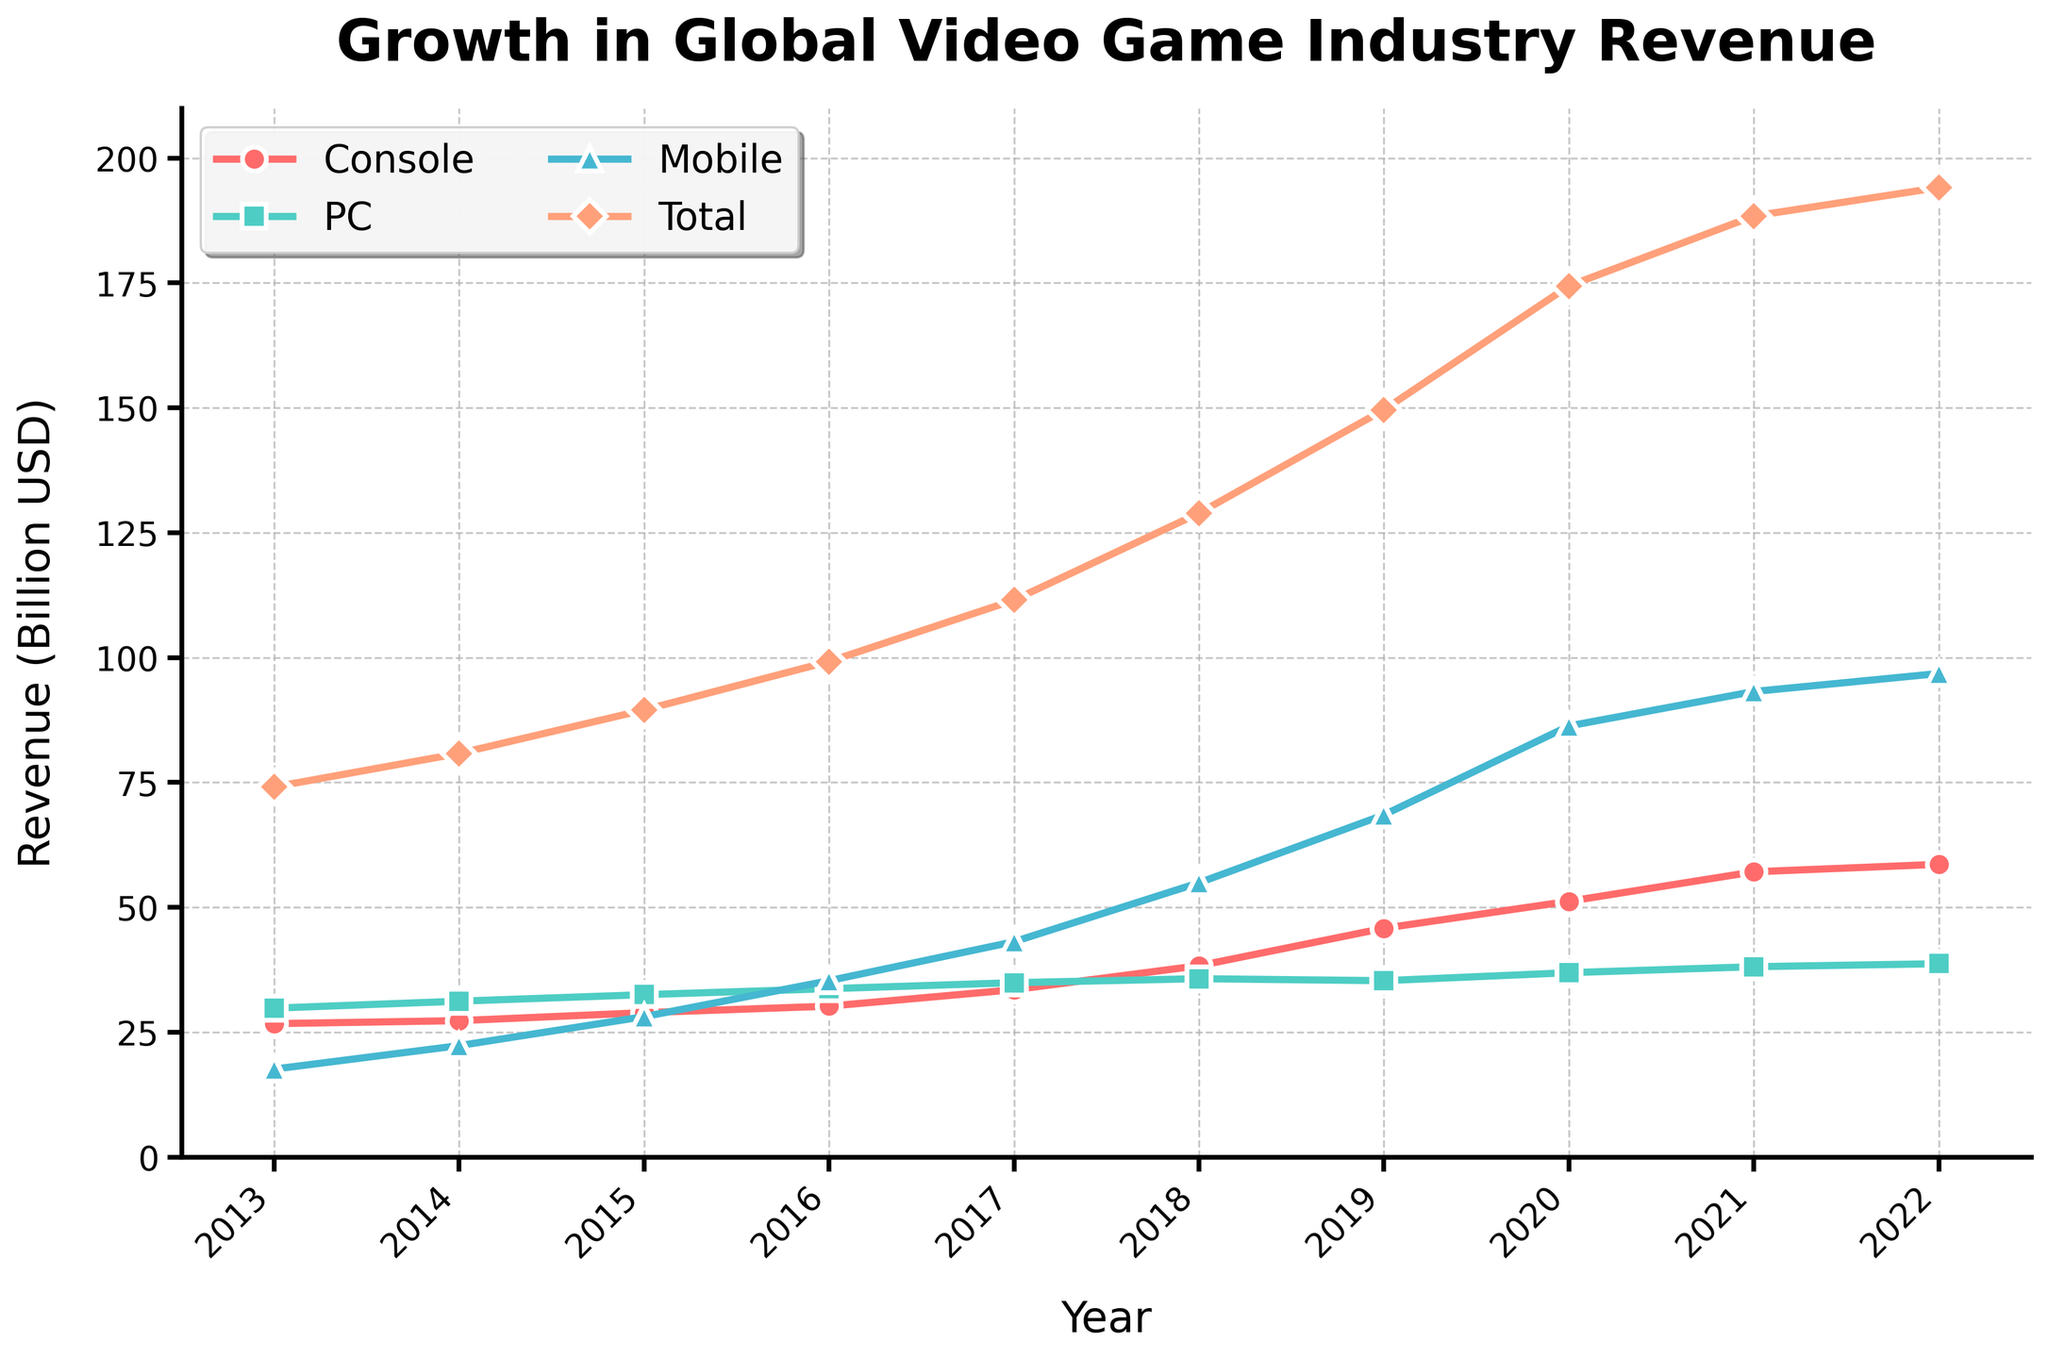Which platform had the highest revenue in 2022? The chart shows revenue for different platforms. In 2022, the Mobile platform's line is the highest, indicating it had the highest revenue.
Answer: Mobile How did the total revenue change from 2013 to 2022? In the chart, the Total revenue line starts at 74.1 billion USD in 2013 and increases to 194.1 billion USD in 2022. Subtracting the 2013 value from the 2022 value: 194.1 - 74.1 = 120 billion USD.
Answer: Increased by 120 billion USD Which year saw the biggest increase in Mobile revenue? The chart visually shows changes in Mobile revenue. The steepest increase appears between 2017 (43.1 billion USD) and 2018 (54.9 billion USD), a difference of 11.8 billion USD.
Answer: 2017 to 2018 Compare Console and PC revenue in 2020. Which was higher? In the chart, observe the lines for Console and PC in 2020. Console revenue is 51.2 billion USD, and PC revenue is 36.9 billion USD. Console revenue is higher.
Answer: Console What is the average annual revenue for the PC platform over the period? Sum the PC revenue values for each year and divide by the number of years: (29.8 + 31.2 + 32.5 + 33.7 + 34.9 + 35.7 + 35.3 + 36.9 + 38.1 + 38.7) / 10 = 34.68 billion USD.
Answer: 34.68 billion USD In which year did Mobile revenue surpass Console revenue? Identify the first year when the Mobile line is above the Console line. This occurs in 2016, where Mobile revenue (35.3 billion USD) surpasses Console revenue (30.2 billion USD).
Answer: 2016 What is the combined revenue of Console and PC platforms in 2021? Add Console and PC revenue for 2021: 57.1 (Console) + 38.1 (PC) = 95.2 billion USD.
Answer: 95.2 billion USD Which platform had the smallest growth from 2013 to 2022? Calculate the difference from 2013 to 2022 for each platform: 
Console: 58.6 - 26.7 = 31.9 billion USD,
PC: 38.7 - 29.8 = 8.9 billion USD,
Mobile: 96.8 - 17.6 = 79.2 billion USD.
The PC platform had the smallest growth.
Answer: PC How much did the Total revenue increase between 2019 and 2020? Subtract the Total revenue in 2019 (149.6 billion USD) from the Total revenue in 2020 (174.4 billion USD): 174.4 - 149.6 = 24.8 billion USD.
Answer: 24.8 billion USD What is the difference between Mobile and PC revenue in 2022? Subtract the PC revenue in 2022 (38.7 billion USD) from the Mobile revenue in 2022 (96.8 billion USD): 96.8 - 38.7 = 58.1 billion USD.
Answer: 58.1 billion USD 